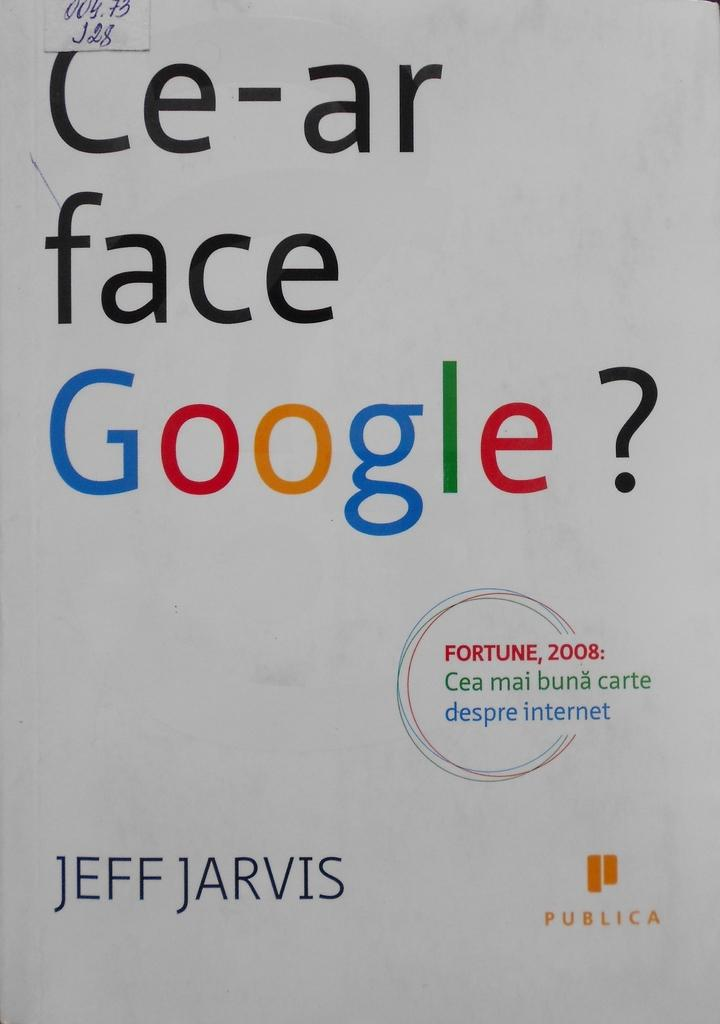<image>
Write a terse but informative summary of the picture. a book titled Ce-ar face google by jeff jarvis 